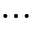Convert formula to latex. <formula><loc_0><loc_0><loc_500><loc_500>\dots</formula> 